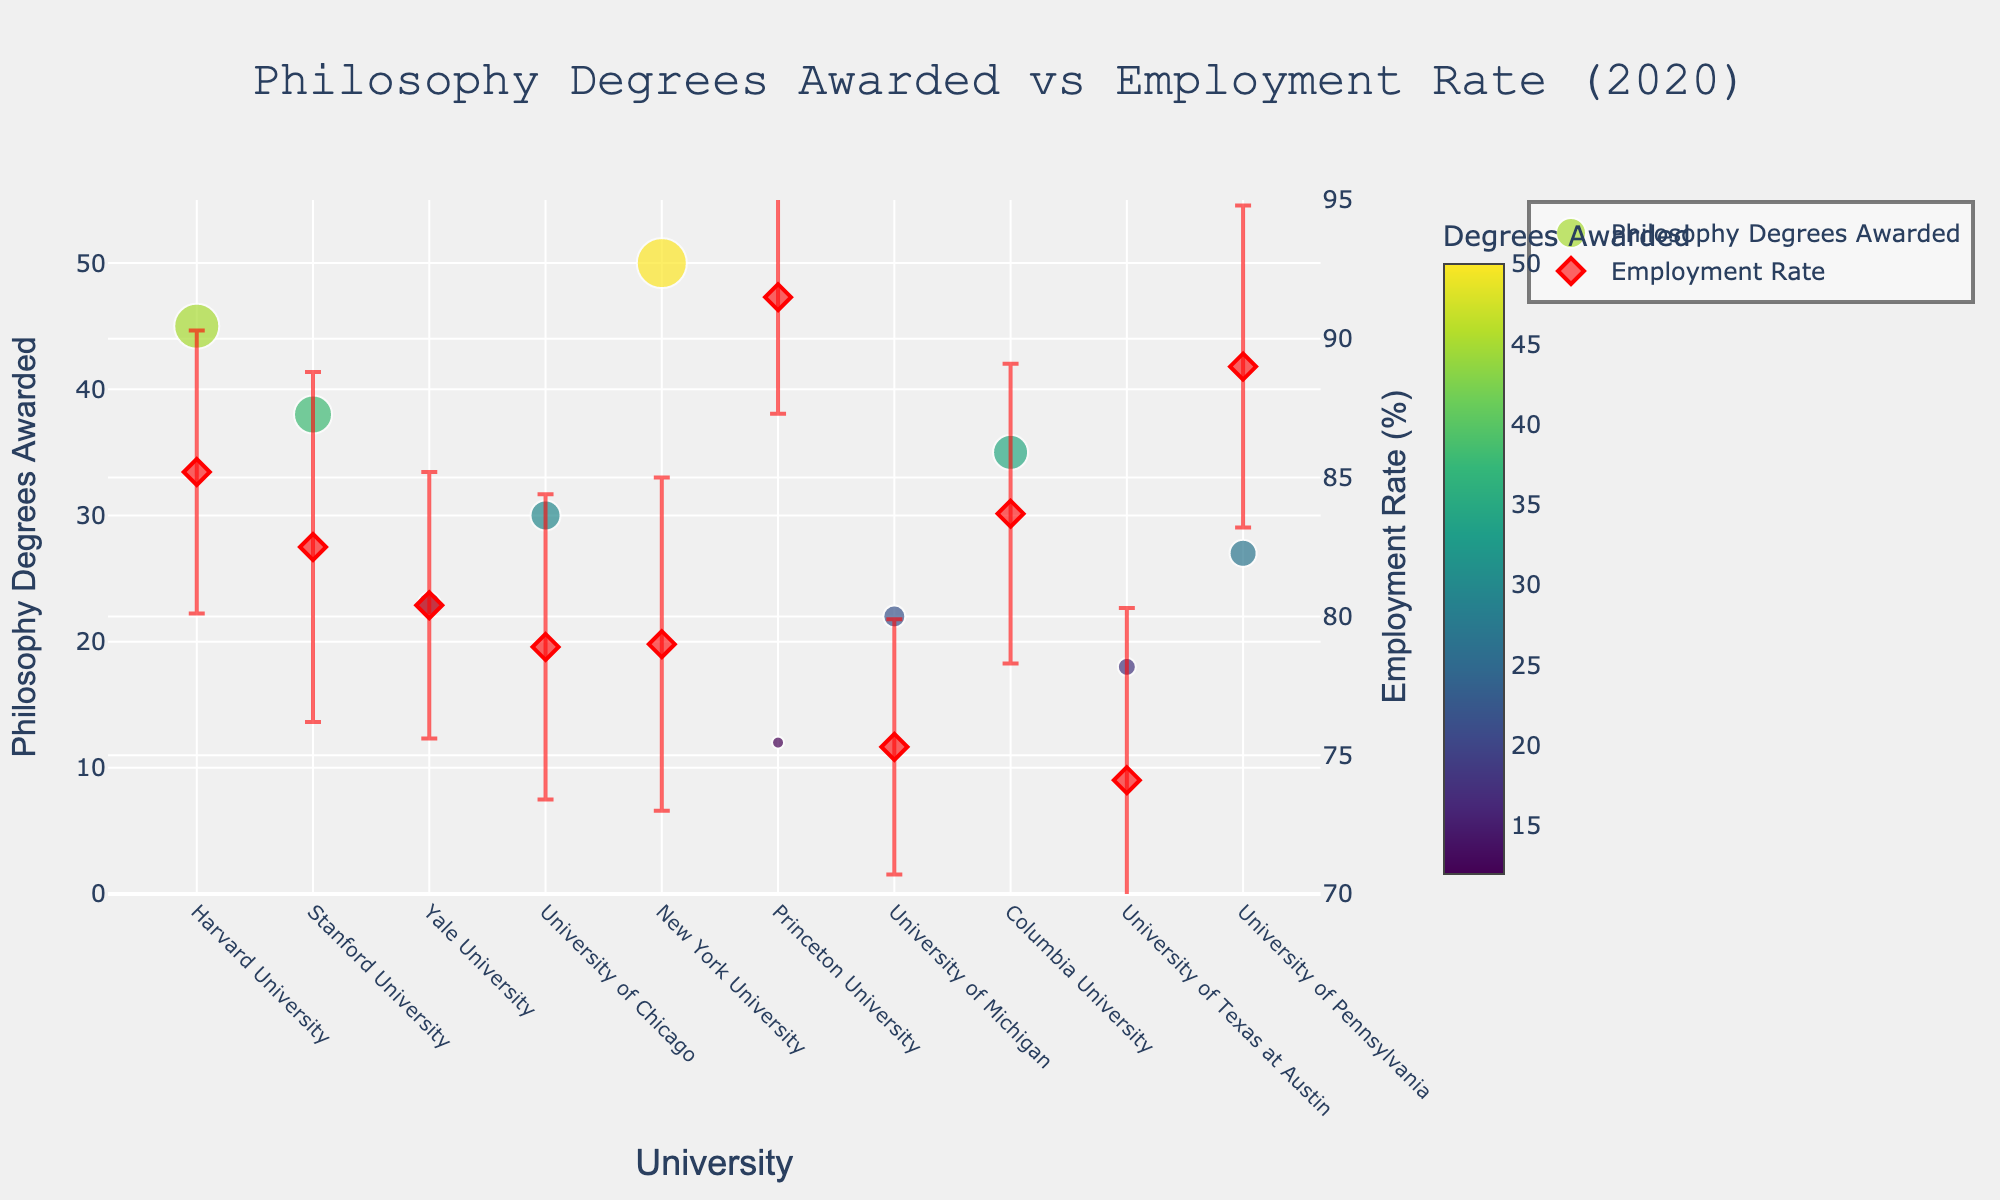What's the title of the plot? The title can be found at the top of the figure. It reads "Philosophy Degrees Awarded vs Employment Rate (2020)".
Answer: Philosophy Degrees Awarded vs Employment Rate (2020) Which university awarded the most philosophy degrees in 2020? By looking at the scatter plot, the largest marker represents the highest number of degrees awarded. New York University has the largest marker, indicating it awarded the most philosophy degrees (50).
Answer: New York University What are the minimum and maximum values for Employment Rate (%) on the secondary y-axis? The secondary y-axis, on the right-hand side, ranges from 70% to 95%. These values are clearly marked on the axis itself.
Answer: 70% and 95% Which university has the highest employment rate for philosophy graduates, and what is it? The highest point on the secondary y-axis (right y-axis) represents the highest employment rate. Princeton University has the highest employment rate, which is 91.5%.
Answer: Princeton University Compare the employment rates of Harvard University and University of Michigan. Which is higher and by how much? Harvard University has an employment rate of 85.2%, while University of Michigan has 75.3%. The difference is calculated by subtracting the smaller rate from the larger: 85.2% - 75.3% = 9.9%.
Answer: Harvard University by 9.9% What is the average number of philosophy degrees awarded across all universities listed? Sum the Philosophy Degrees Awarded for all universities and divide by the number of universities. (45 + 38 + 23 + 30 + 50 + 12 + 22 + 35 + 18 + 27) / 10 = 30.
Answer: 30 Which university has both a low number of philosophy degrees awarded and a high employment rate? Princeton University awarded 12 philosophy degrees, which is low, and has an employment rate of 91.5%, which is high.
Answer: Princeton University How many universities have an employment rate above 80%? By inspecting each point in the plot on the right y-axis, the universities are: Harvard, Stanford, Yale, Columbia, Princeton, and University of Pennsylvania, totaling 6 universities.
Answer: 6 What is the standard deviation of employment rates for Yale University? Standard deviations are shown as error bars extending vertically from each employment rate point. For Yale University, the error bar length reveals an SD of 4.8%.
Answer: 4.8% What is the relationship between philosophy degrees awarded and employment rates at New York University? From the plot, NYU awarded 50 philosophy degrees, and its employment rate is approximately 79%, with a standard deviation of 6.0%.
Answer: 50 degrees awarded, 79% employment rate 